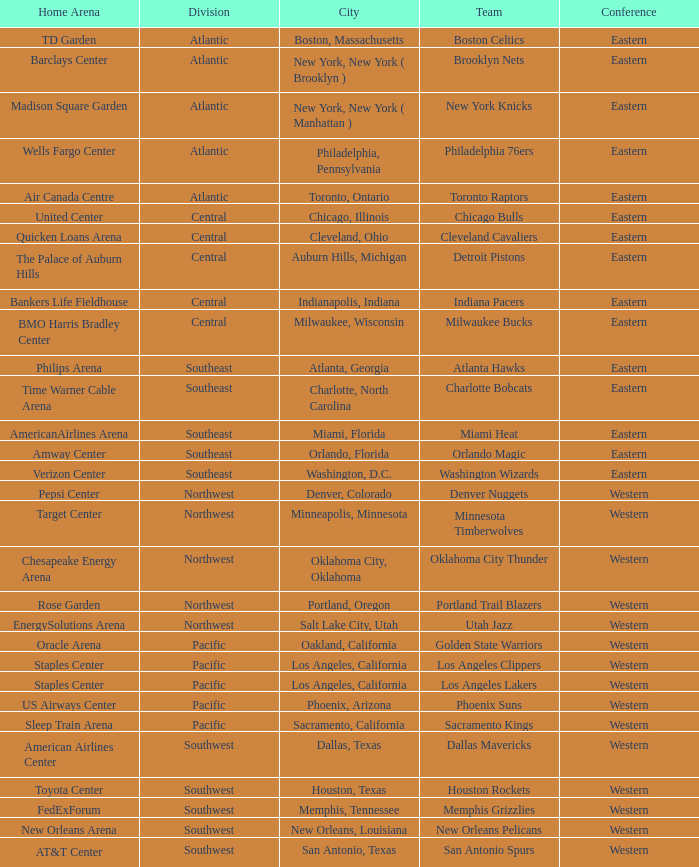Which conference is in Portland, Oregon? Western. 